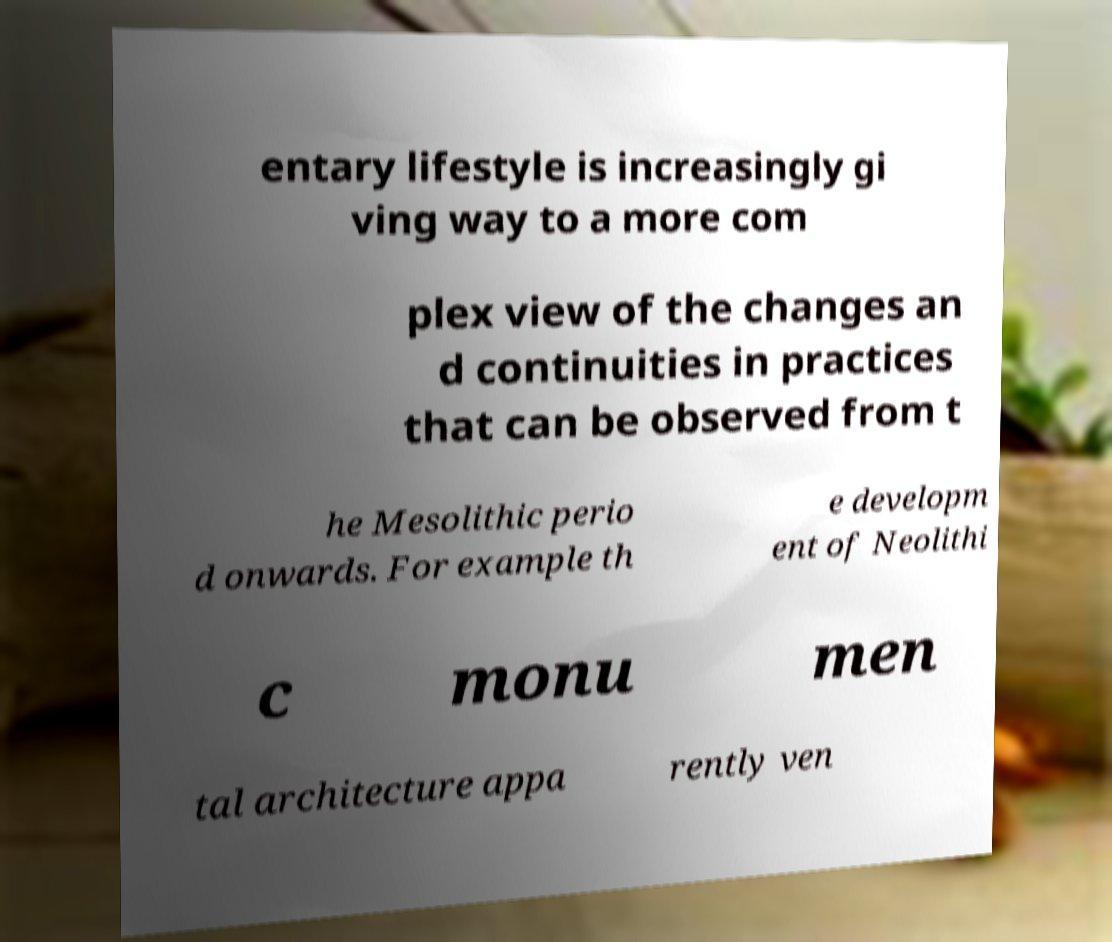Could you assist in decoding the text presented in this image and type it out clearly? entary lifestyle is increasingly gi ving way to a more com plex view of the changes an d continuities in practices that can be observed from t he Mesolithic perio d onwards. For example th e developm ent of Neolithi c monu men tal architecture appa rently ven 